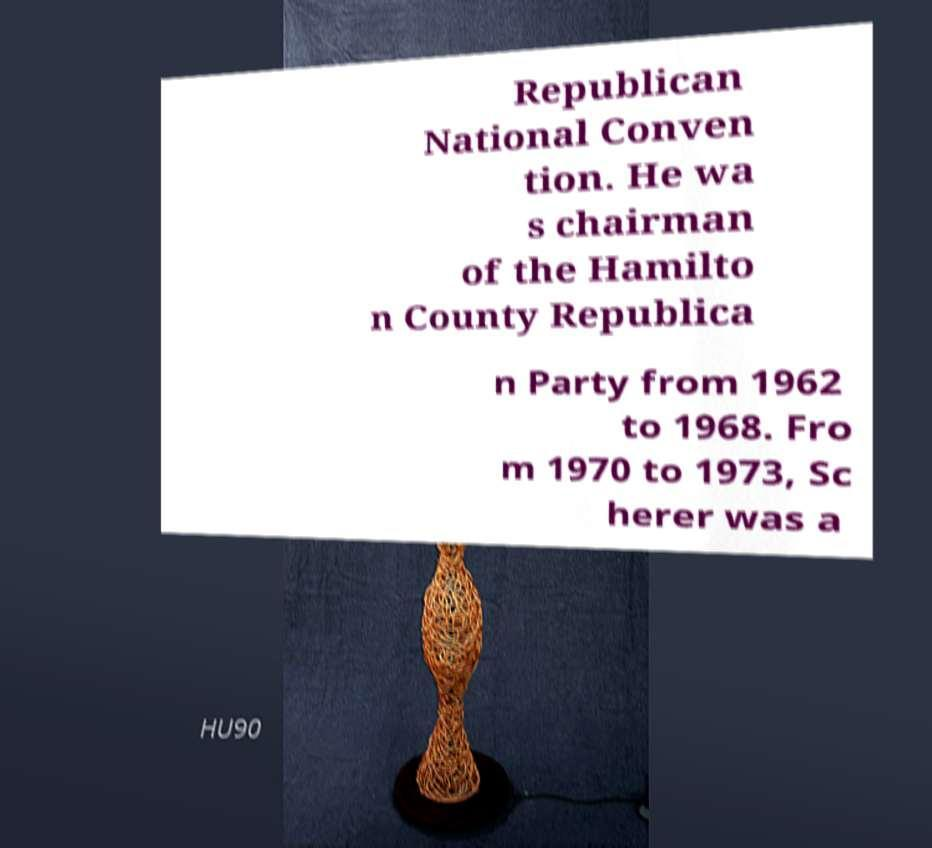Can you read and provide the text displayed in the image?This photo seems to have some interesting text. Can you extract and type it out for me? Republican National Conven tion. He wa s chairman of the Hamilto n County Republica n Party from 1962 to 1968. Fro m 1970 to 1973, Sc herer was a 